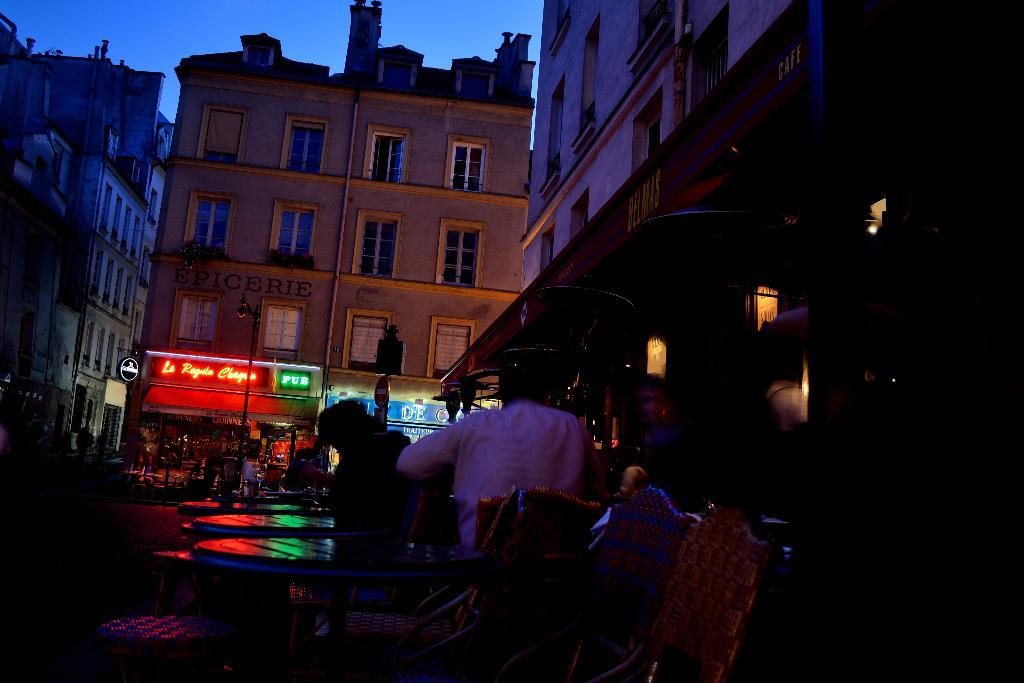What type of location is shown in the image? The image depicts a busy street. What can be seen in the background of the image? There are buildings around the area. Are there any people in the image? Yes, there are people present on the street. What time of day is it in the image? It is night time in the image. What is present in front of the shops? There are hoardings in front of the shops. What type of tin can be seen in the image? There is no tin present in the image. What is the weight of the art displayed on the hoardings? There is no art displayed on the hoardings in the image, so it is not possible to determine the weight of any art. 